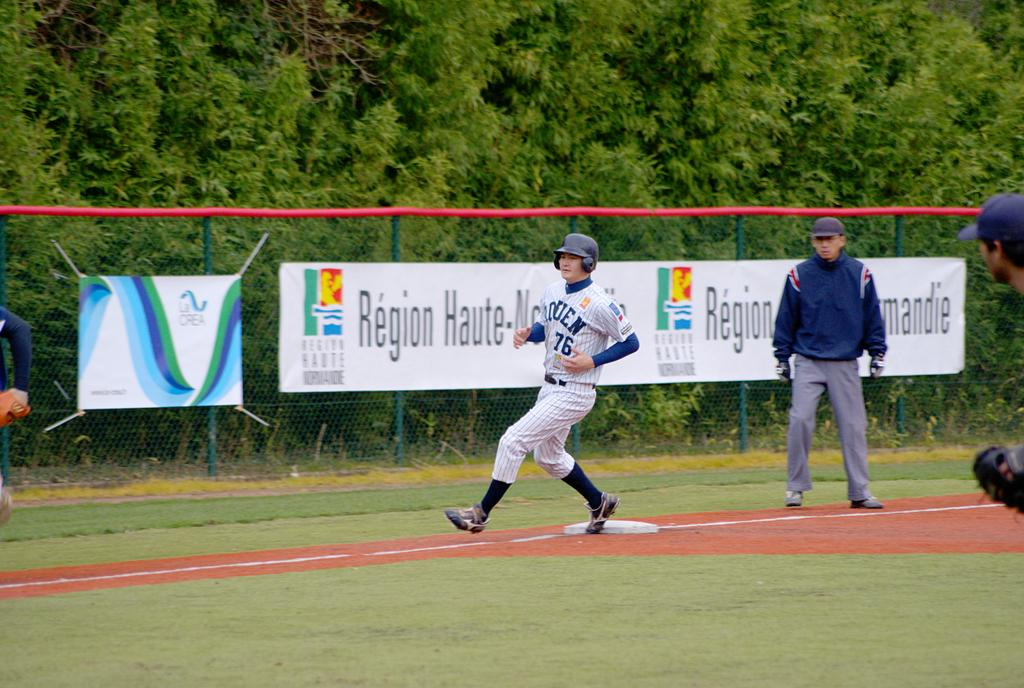<image>
Offer a succinct explanation of the picture presented. the runner is wearing a number 76 jersey 